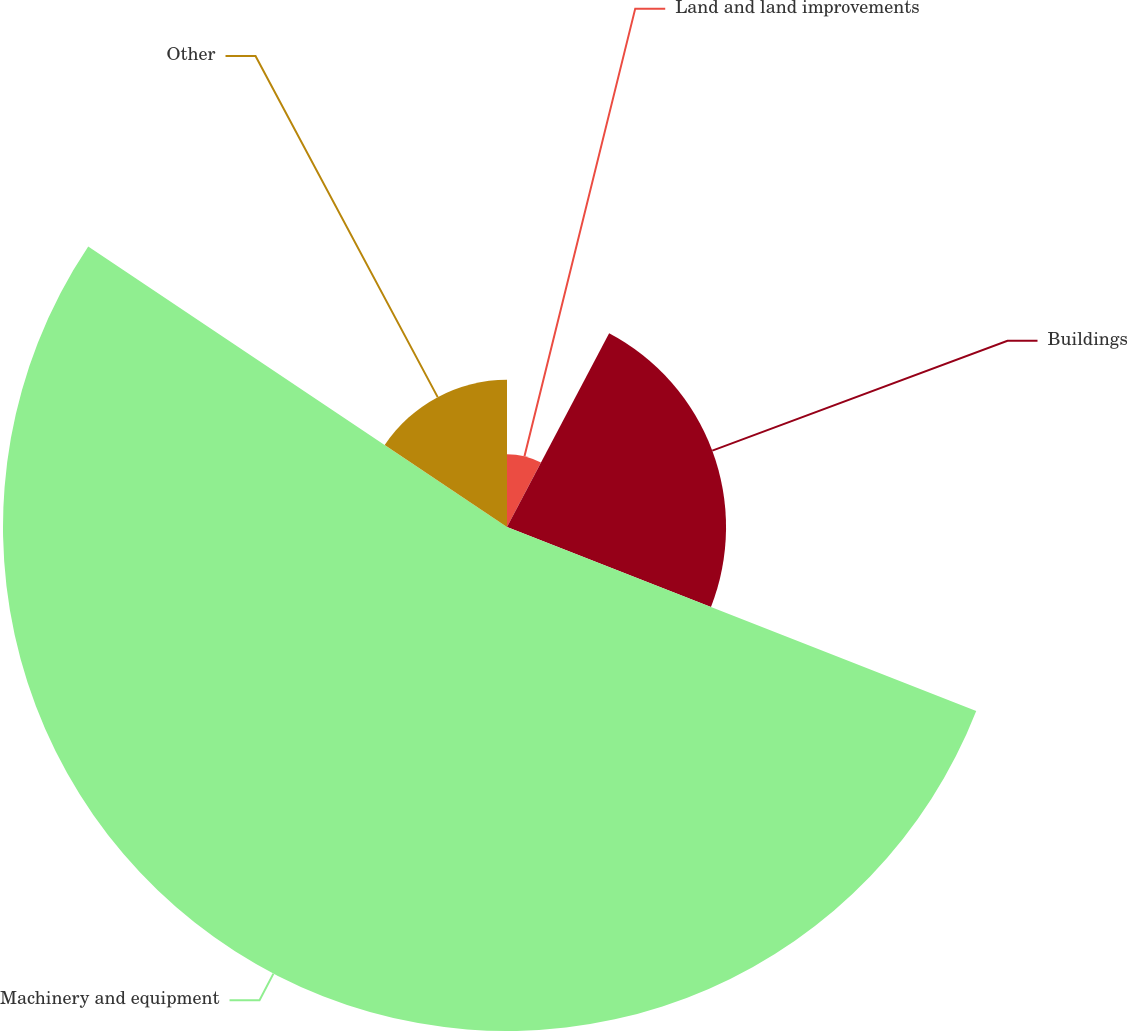<chart> <loc_0><loc_0><loc_500><loc_500><pie_chart><fcel>Land and land improvements<fcel>Buildings<fcel>Machinery and equipment<fcel>Other<nl><fcel>7.72%<fcel>23.23%<fcel>53.45%<fcel>15.61%<nl></chart> 